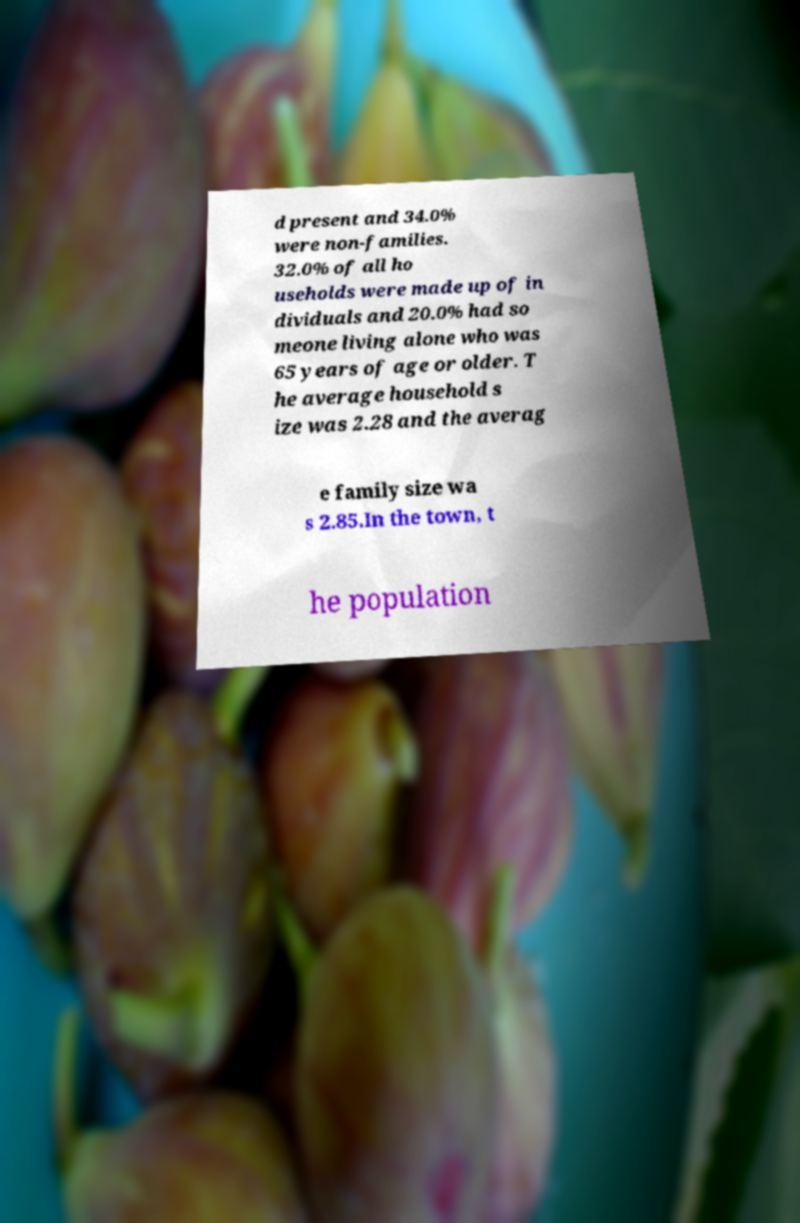Please read and relay the text visible in this image. What does it say? d present and 34.0% were non-families. 32.0% of all ho useholds were made up of in dividuals and 20.0% had so meone living alone who was 65 years of age or older. T he average household s ize was 2.28 and the averag e family size wa s 2.85.In the town, t he population 